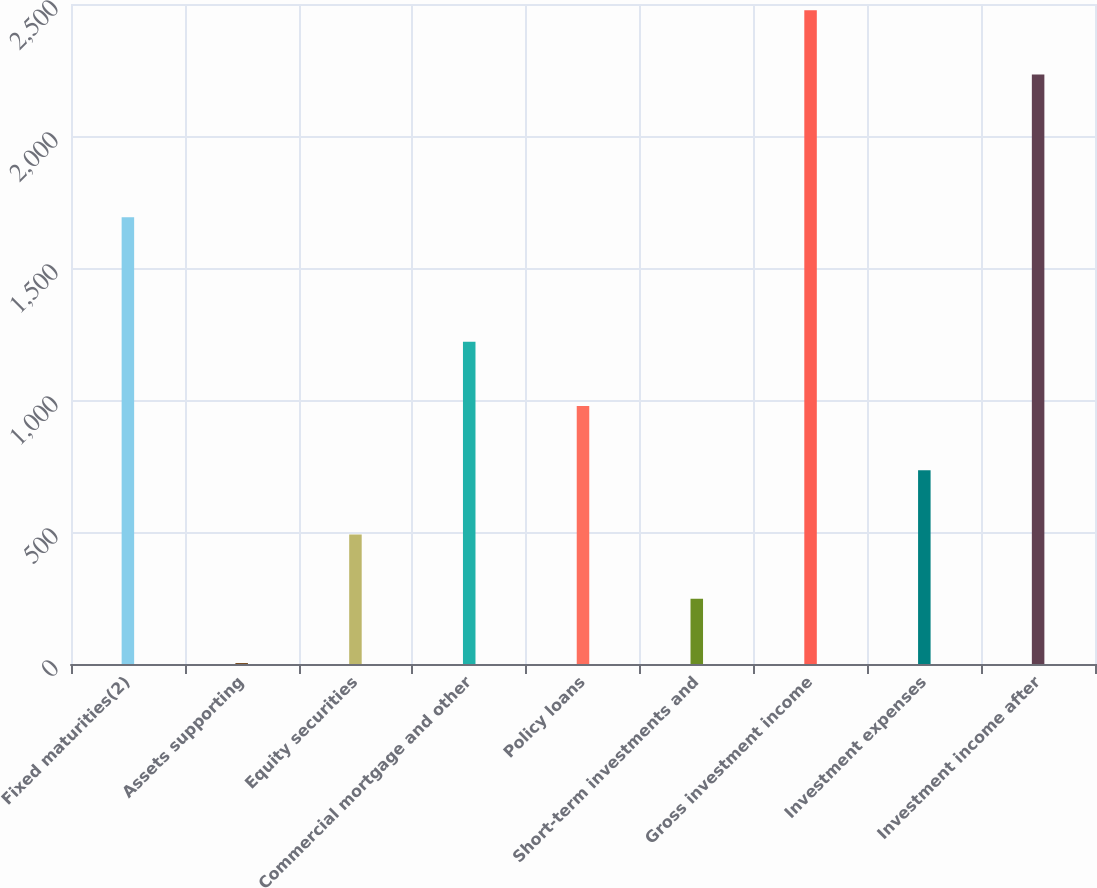Convert chart. <chart><loc_0><loc_0><loc_500><loc_500><bar_chart><fcel>Fixed maturities(2)<fcel>Assets supporting<fcel>Equity securities<fcel>Commercial mortgage and other<fcel>Policy loans<fcel>Short-term investments and<fcel>Gross investment income<fcel>Investment expenses<fcel>Investment income after<nl><fcel>1692<fcel>3.52<fcel>490.22<fcel>1220.27<fcel>976.92<fcel>246.87<fcel>2476.35<fcel>733.57<fcel>2233<nl></chart> 